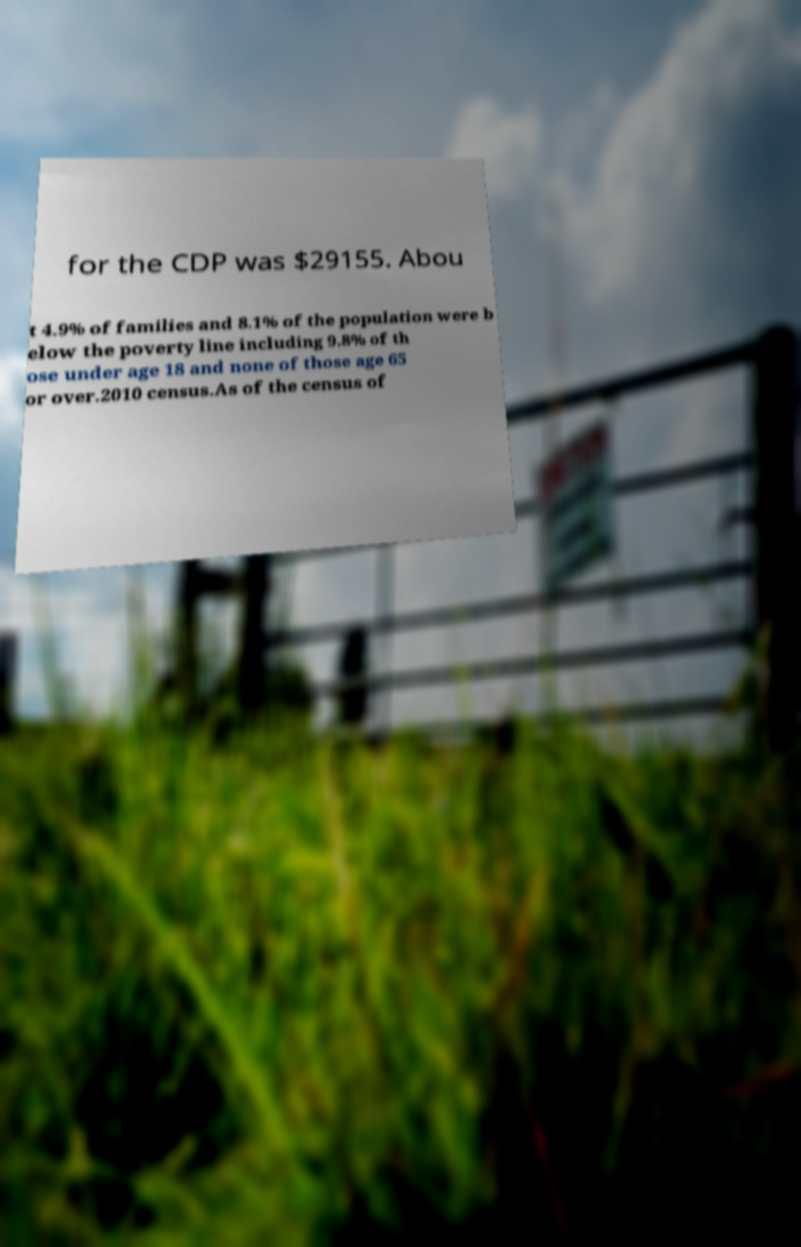For documentation purposes, I need the text within this image transcribed. Could you provide that? for the CDP was $29155. Abou t 4.9% of families and 8.1% of the population were b elow the poverty line including 9.8% of th ose under age 18 and none of those age 65 or over.2010 census.As of the census of 